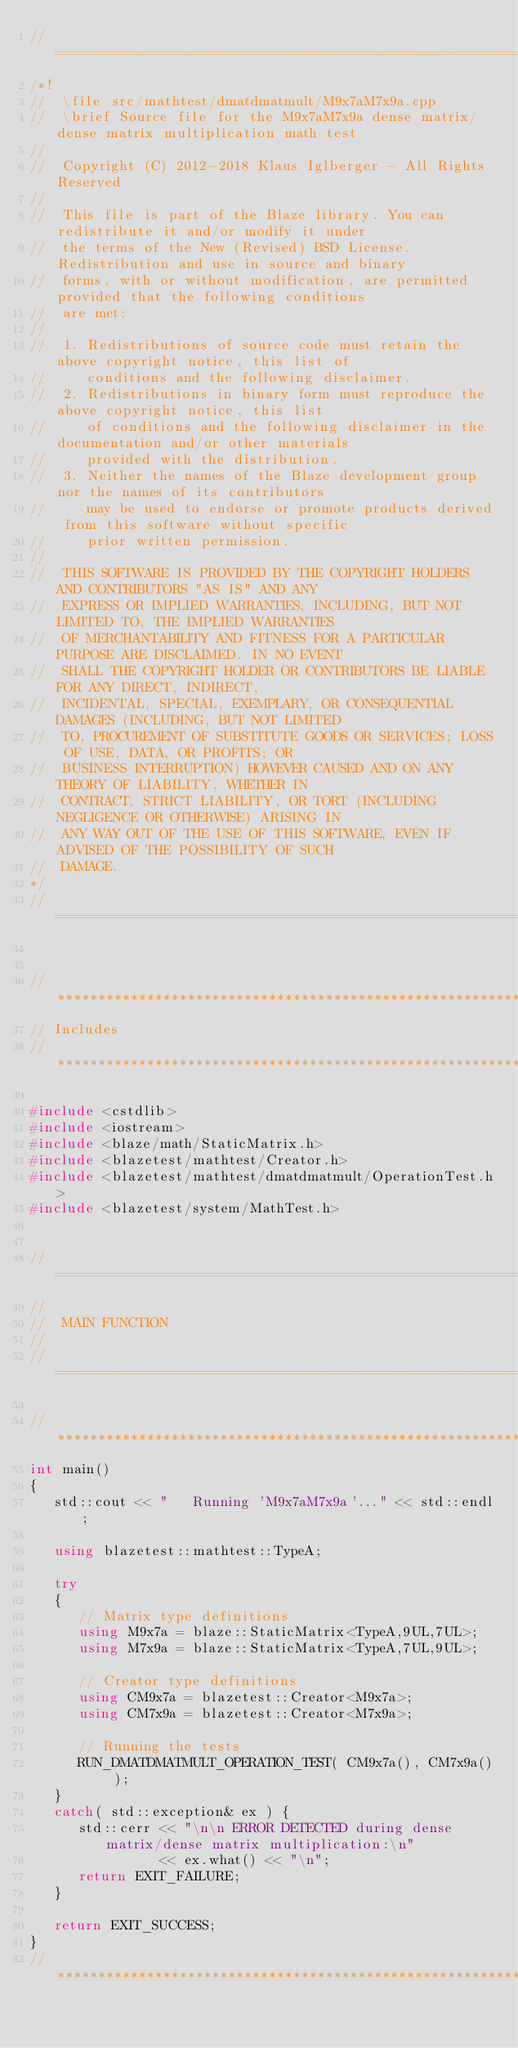Convert code to text. <code><loc_0><loc_0><loc_500><loc_500><_C++_>//=================================================================================================
/*!
//  \file src/mathtest/dmatdmatmult/M9x7aM7x9a.cpp
//  \brief Source file for the M9x7aM7x9a dense matrix/dense matrix multiplication math test
//
//  Copyright (C) 2012-2018 Klaus Iglberger - All Rights Reserved
//
//  This file is part of the Blaze library. You can redistribute it and/or modify it under
//  the terms of the New (Revised) BSD License. Redistribution and use in source and binary
//  forms, with or without modification, are permitted provided that the following conditions
//  are met:
//
//  1. Redistributions of source code must retain the above copyright notice, this list of
//     conditions and the following disclaimer.
//  2. Redistributions in binary form must reproduce the above copyright notice, this list
//     of conditions and the following disclaimer in the documentation and/or other materials
//     provided with the distribution.
//  3. Neither the names of the Blaze development group nor the names of its contributors
//     may be used to endorse or promote products derived from this software without specific
//     prior written permission.
//
//  THIS SOFTWARE IS PROVIDED BY THE COPYRIGHT HOLDERS AND CONTRIBUTORS "AS IS" AND ANY
//  EXPRESS OR IMPLIED WARRANTIES, INCLUDING, BUT NOT LIMITED TO, THE IMPLIED WARRANTIES
//  OF MERCHANTABILITY AND FITNESS FOR A PARTICULAR PURPOSE ARE DISCLAIMED. IN NO EVENT
//  SHALL THE COPYRIGHT HOLDER OR CONTRIBUTORS BE LIABLE FOR ANY DIRECT, INDIRECT,
//  INCIDENTAL, SPECIAL, EXEMPLARY, OR CONSEQUENTIAL DAMAGES (INCLUDING, BUT NOT LIMITED
//  TO, PROCUREMENT OF SUBSTITUTE GOODS OR SERVICES; LOSS OF USE, DATA, OR PROFITS; OR
//  BUSINESS INTERRUPTION) HOWEVER CAUSED AND ON ANY THEORY OF LIABILITY, WHETHER IN
//  CONTRACT, STRICT LIABILITY, OR TORT (INCLUDING NEGLIGENCE OR OTHERWISE) ARISING IN
//  ANY WAY OUT OF THE USE OF THIS SOFTWARE, EVEN IF ADVISED OF THE POSSIBILITY OF SUCH
//  DAMAGE.
*/
//=================================================================================================


//*************************************************************************************************
// Includes
//*************************************************************************************************

#include <cstdlib>
#include <iostream>
#include <blaze/math/StaticMatrix.h>
#include <blazetest/mathtest/Creator.h>
#include <blazetest/mathtest/dmatdmatmult/OperationTest.h>
#include <blazetest/system/MathTest.h>


//=================================================================================================
//
//  MAIN FUNCTION
//
//=================================================================================================

//*************************************************************************************************
int main()
{
   std::cout << "   Running 'M9x7aM7x9a'..." << std::endl;

   using blazetest::mathtest::TypeA;

   try
   {
      // Matrix type definitions
      using M9x7a = blaze::StaticMatrix<TypeA,9UL,7UL>;
      using M7x9a = blaze::StaticMatrix<TypeA,7UL,9UL>;

      // Creator type definitions
      using CM9x7a = blazetest::Creator<M9x7a>;
      using CM7x9a = blazetest::Creator<M7x9a>;

      // Running the tests
      RUN_DMATDMATMULT_OPERATION_TEST( CM9x7a(), CM7x9a() );
   }
   catch( std::exception& ex ) {
      std::cerr << "\n\n ERROR DETECTED during dense matrix/dense matrix multiplication:\n"
                << ex.what() << "\n";
      return EXIT_FAILURE;
   }

   return EXIT_SUCCESS;
}
//*************************************************************************************************
</code> 